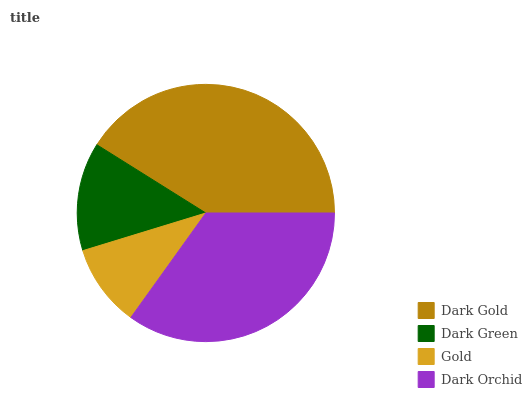Is Gold the minimum?
Answer yes or no. Yes. Is Dark Gold the maximum?
Answer yes or no. Yes. Is Dark Green the minimum?
Answer yes or no. No. Is Dark Green the maximum?
Answer yes or no. No. Is Dark Gold greater than Dark Green?
Answer yes or no. Yes. Is Dark Green less than Dark Gold?
Answer yes or no. Yes. Is Dark Green greater than Dark Gold?
Answer yes or no. No. Is Dark Gold less than Dark Green?
Answer yes or no. No. Is Dark Orchid the high median?
Answer yes or no. Yes. Is Dark Green the low median?
Answer yes or no. Yes. Is Gold the high median?
Answer yes or no. No. Is Dark Gold the low median?
Answer yes or no. No. 